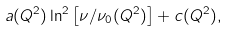<formula> <loc_0><loc_0><loc_500><loc_500>a ( Q ^ { 2 } ) \ln ^ { 2 } \left [ \nu / \nu _ { 0 } ( Q ^ { 2 } ) \right ] + c ( Q ^ { 2 } ) ,</formula> 